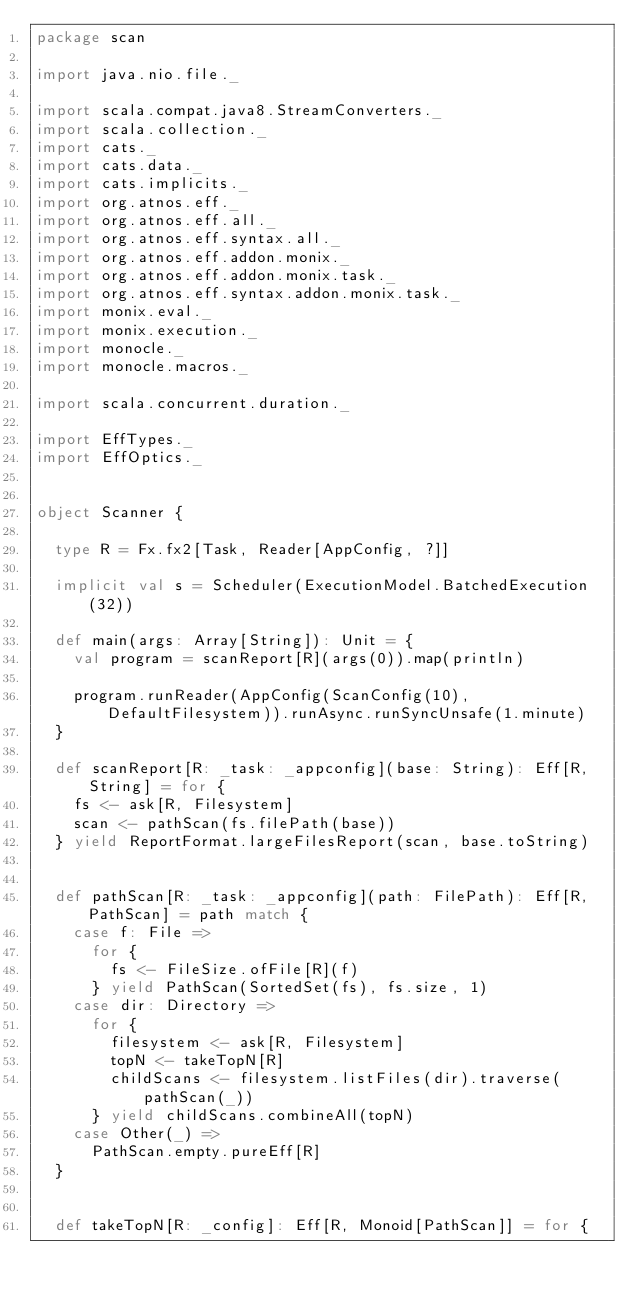<code> <loc_0><loc_0><loc_500><loc_500><_Scala_>package scan

import java.nio.file._

import scala.compat.java8.StreamConverters._
import scala.collection._
import cats._
import cats.data._
import cats.implicits._
import org.atnos.eff._
import org.atnos.eff.all._
import org.atnos.eff.syntax.all._
import org.atnos.eff.addon.monix._
import org.atnos.eff.addon.monix.task._
import org.atnos.eff.syntax.addon.monix.task._
import monix.eval._
import monix.execution._
import monocle._
import monocle.macros._

import scala.concurrent.duration._

import EffTypes._
import EffOptics._


object Scanner {

  type R = Fx.fx2[Task, Reader[AppConfig, ?]]

  implicit val s = Scheduler(ExecutionModel.BatchedExecution(32))

  def main(args: Array[String]): Unit = {
    val program = scanReport[R](args(0)).map(println)

    program.runReader(AppConfig(ScanConfig(10), DefaultFilesystem)).runAsync.runSyncUnsafe(1.minute)
  }

  def scanReport[R: _task: _appconfig](base: String): Eff[R, String] = for {
    fs <- ask[R, Filesystem]
    scan <- pathScan(fs.filePath(base))
  } yield ReportFormat.largeFilesReport(scan, base.toString)


  def pathScan[R: _task: _appconfig](path: FilePath): Eff[R, PathScan] = path match {
    case f: File =>
      for {
        fs <- FileSize.ofFile[R](f)
      } yield PathScan(SortedSet(fs), fs.size, 1)
    case dir: Directory =>
      for {
        filesystem <- ask[R, Filesystem]
        topN <- takeTopN[R]
        childScans <- filesystem.listFiles(dir).traverse(pathScan(_))
      } yield childScans.combineAll(topN)
    case Other(_) =>
      PathScan.empty.pureEff[R]
  }


  def takeTopN[R: _config]: Eff[R, Monoid[PathScan]] = for {</code> 